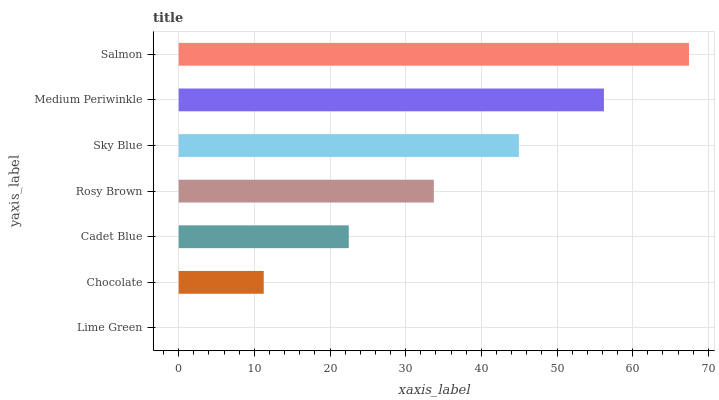Is Lime Green the minimum?
Answer yes or no. Yes. Is Salmon the maximum?
Answer yes or no. Yes. Is Chocolate the minimum?
Answer yes or no. No. Is Chocolate the maximum?
Answer yes or no. No. Is Chocolate greater than Lime Green?
Answer yes or no. Yes. Is Lime Green less than Chocolate?
Answer yes or no. Yes. Is Lime Green greater than Chocolate?
Answer yes or no. No. Is Chocolate less than Lime Green?
Answer yes or no. No. Is Rosy Brown the high median?
Answer yes or no. Yes. Is Rosy Brown the low median?
Answer yes or no. Yes. Is Sky Blue the high median?
Answer yes or no. No. Is Salmon the low median?
Answer yes or no. No. 